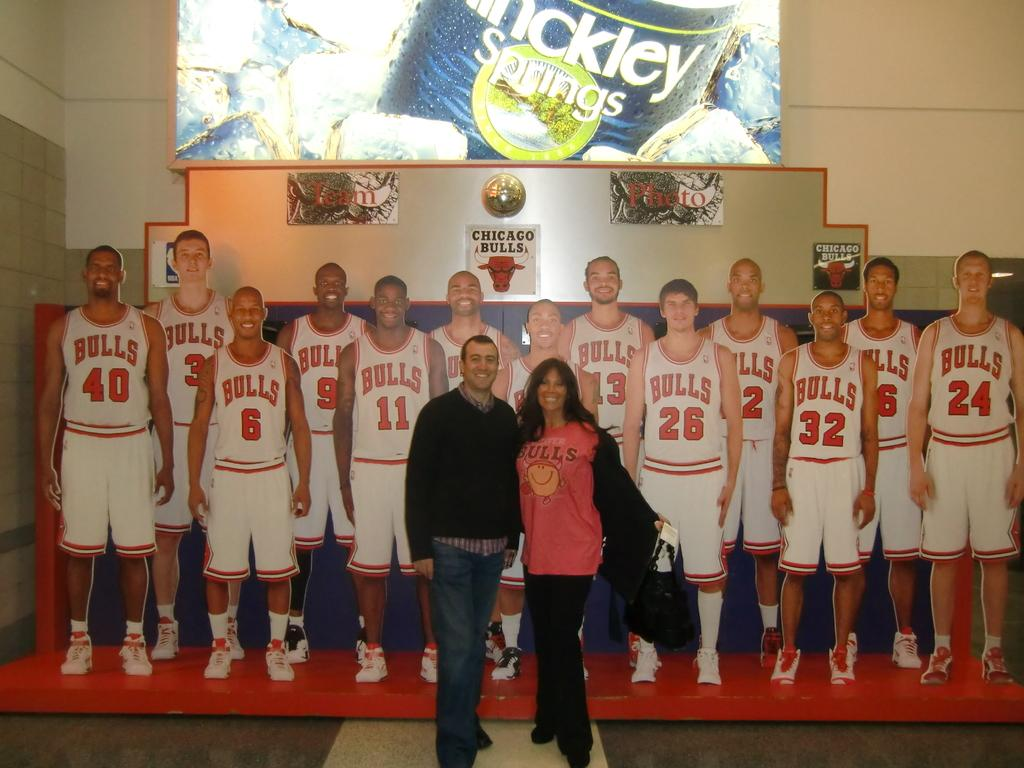<image>
Describe the image concisely. A couple takes a photo in front of a representation of the Chicago Bulls team. 